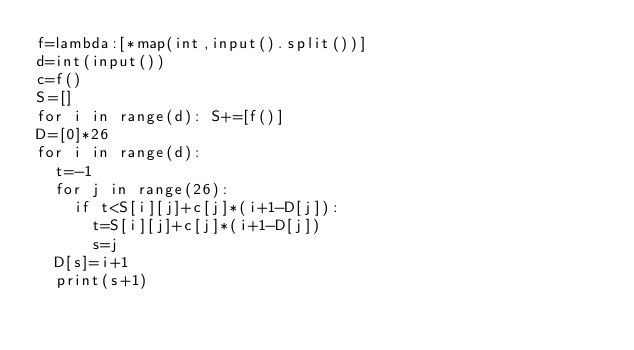<code> <loc_0><loc_0><loc_500><loc_500><_Python_>f=lambda:[*map(int,input().split())]
d=int(input())
c=f()
S=[]
for i in range(d): S+=[f()]
D=[0]*26
for i in range(d):
  t=-1
  for j in range(26):
    if t<S[i][j]+c[j]*(i+1-D[j]):
      t=S[i][j]+c[j]*(i+1-D[j])
      s=j
  D[s]=i+1
  print(s+1)</code> 